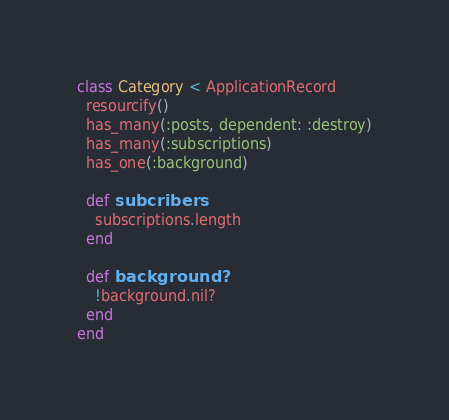Convert code to text. <code><loc_0><loc_0><loc_500><loc_500><_Ruby_>class Category < ApplicationRecord
  resourcify()
  has_many(:posts, dependent: :destroy)
  has_many(:subscriptions)
  has_one(:background)

  def subcribers
    subscriptions.length
  end

  def background?
    !background.nil?
  end
end
</code> 